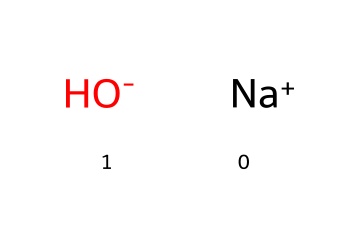What is the name of the chemical represented here? The chemical is sodium hydroxide, as indicated by the presence of the sodium ion (Na+) and the hydroxide ion (OH-).
Answer: sodium hydroxide How many atoms are in the molecule of sodium hydroxide? Sodium hydroxide consists of two distinct ions: one sodium atom and one hydroxide group containing one oxygen and one hydrogen, totaling three atoms.
Answer: three What charge does the sodium ion carry? The sodium ion is represented as Na+, which indicates it carries a positive charge, signified by the '+' in the notation.
Answer: positive What type of chemical is sodium hydroxide? Sodium hydroxide is classified as a strong base, which can be identified by its ability to dissociate completely in water and produce hydroxide ions (OH-).
Answer: strong base Why is sodium hydroxide important in household drain cleaners? Sodium hydroxide is important in household drain cleaners because it effectively saponifies fats and dissolves organic materials, making it an effective agent for clearing clogs.
Answer: effective agent How does sodium hydroxide affect pH levels in a solution? Sodium hydroxide increases the pH of a solution because it introduces hydroxide ions (OH-), which makes the solution more alkaline or basic.
Answer: increases pH What is the functional group present in sodium hydroxide? The functional group present is the hydroxide ion (OH-), which is characteristic of bases and contributes to its chemical properties.
Answer: hydroxide 